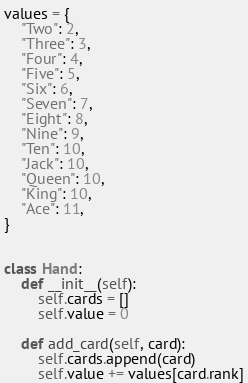Convert code to text. <code><loc_0><loc_0><loc_500><loc_500><_Python_>values = {
    "Two": 2,
    "Three": 3,
    "Four": 4,
    "Five": 5,
    "Six": 6,
    "Seven": 7,
    "Eight": 8,
    "Nine": 9,
    "Ten": 10,
    "Jack": 10,
    "Queen": 10,
    "King": 10,
    "Ace": 11,
}


class Hand:
    def __init__(self):
        self.cards = []
        self.value = 0

    def add_card(self, card):
        self.cards.append(card)
        self.value += values[card.rank]
</code> 